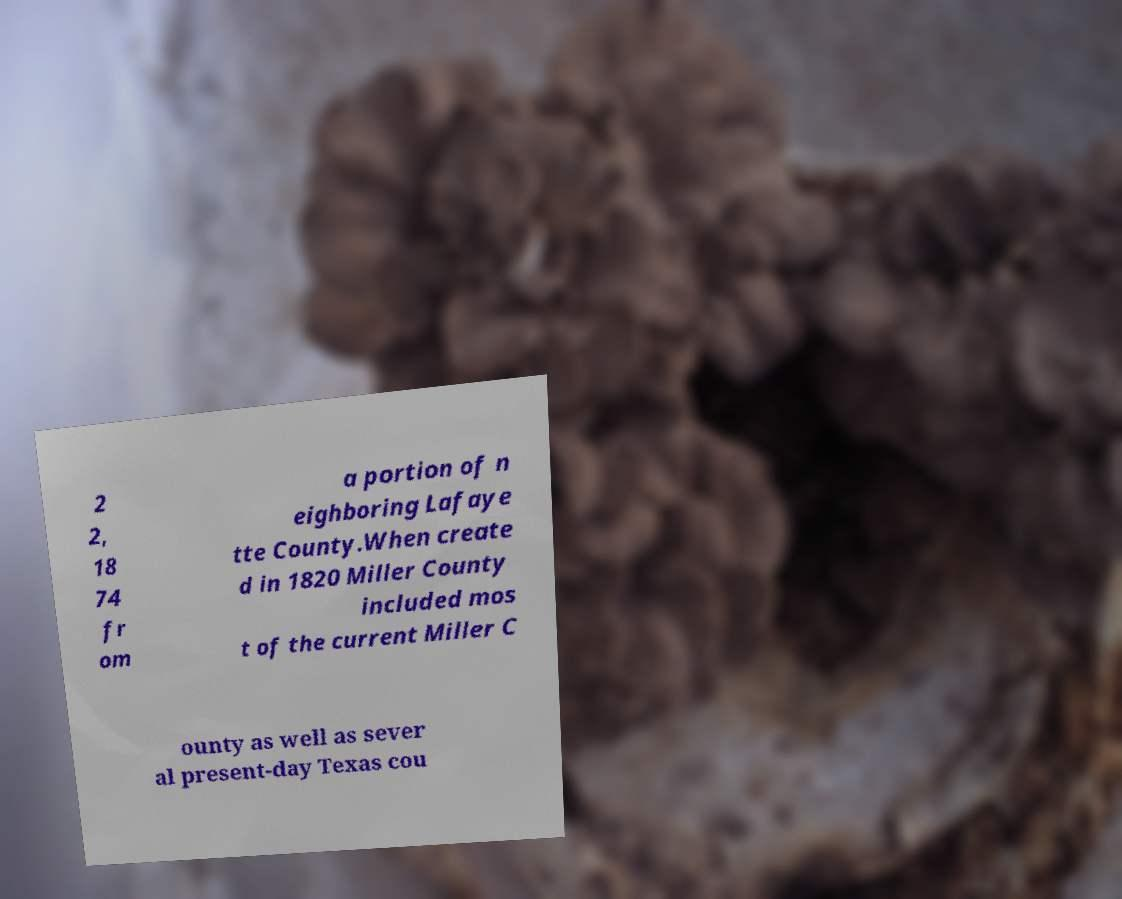I need the written content from this picture converted into text. Can you do that? 2 2, 18 74 fr om a portion of n eighboring Lafaye tte County.When create d in 1820 Miller County included mos t of the current Miller C ounty as well as sever al present-day Texas cou 